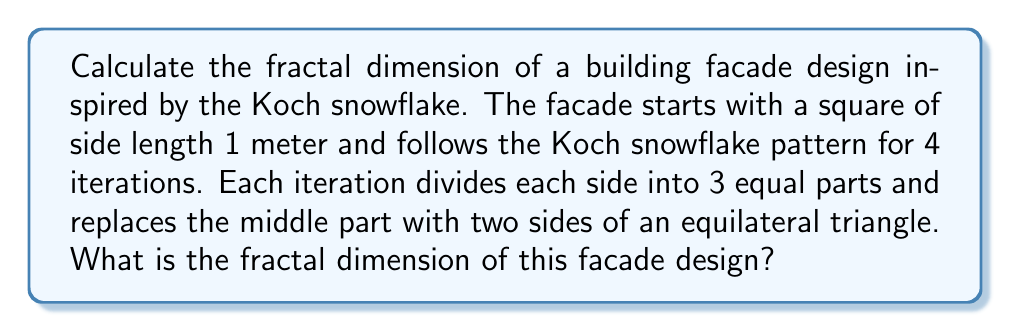Show me your answer to this math problem. To calculate the fractal dimension of this facade design, we'll use the box-counting method. The fractal dimension $D$ is given by:

$$D = \frac{\log N}{\log(1/r)}$$

Where $N$ is the number of self-similar pieces and $r$ is the scale factor.

For the Koch snowflake pattern:
1. In each iteration, each line segment is replaced by 4 smaller segments.
2. The length of each new segment is 1/3 of the original.

Therefore:
$N = 4$ (number of self-similar pieces)
$r = 1/3$ (scale factor)

Substituting these values into the formula:

$$D = \frac{\log 4}{\log(1/(1/3))} = \frac{\log 4}{\log 3}$$

Using a calculator or computing software:

$$D \approx 1.2618595071429148$$

This value represents the fractal dimension of the Koch snowflake pattern applied to each side of the square facade.

[asy]
size(200);
pair A=(0,0), B=(1,0), C=(1,1), D=(0,1);
void koch(pair A, pair B, int n) {
  if(n==0) draw(A--B);
  else {
    pair C = A + (B-A)/3;
    pair D = B - (B-A)/3;
    pair E = rotate(60)*(D-C) + C;
    koch(A,C,n-1);
    koch(C,E,n-1);
    koch(E,D,n-1);
    koch(D,B,n-1);
  }
}
koch(A,B,4);
koch(B,C,4);
koch(C,D,4);
koch(D,A,4);
[/asy]

The image above shows the facade design after 4 iterations of the Koch snowflake pattern applied to each side of the square.
Answer: $\frac{\log 4}{\log 3} \approx 1.2619$ 